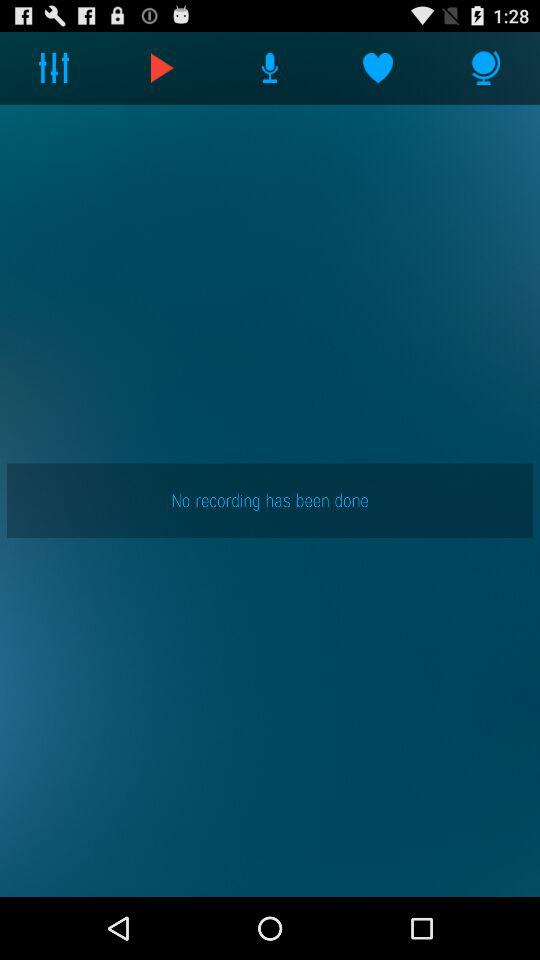What is the name of the application?
When the provided information is insufficient, respond with <no answer>. <no answer> 